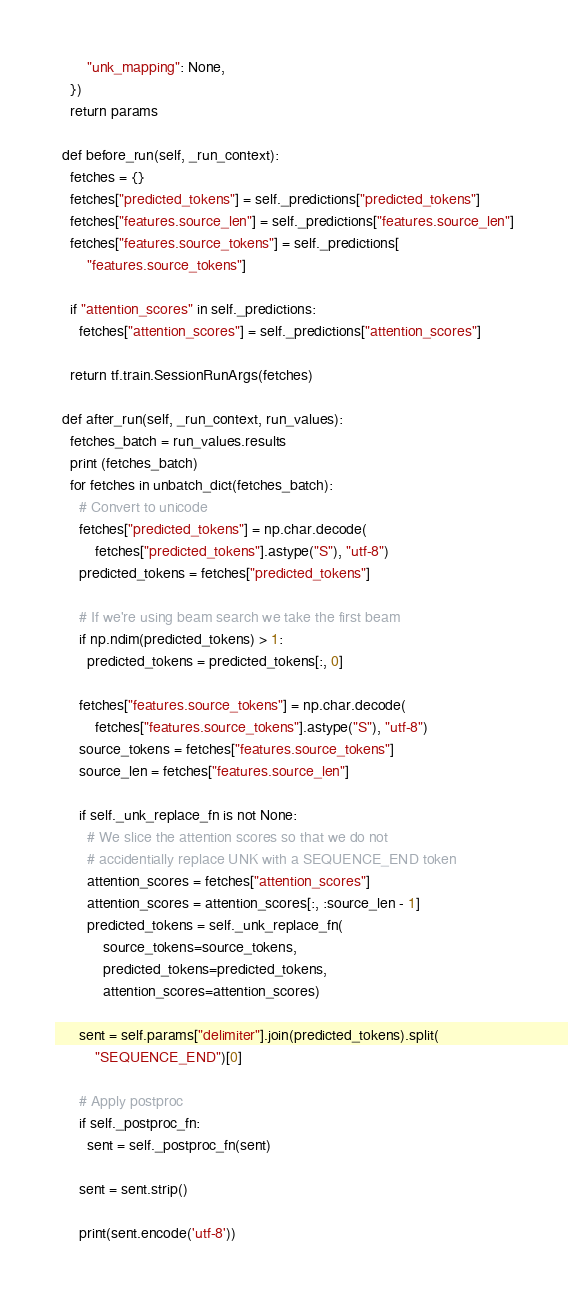<code> <loc_0><loc_0><loc_500><loc_500><_Python_>        "unk_mapping": None,
    })
    return params

  def before_run(self, _run_context):
    fetches = {}
    fetches["predicted_tokens"] = self._predictions["predicted_tokens"]
    fetches["features.source_len"] = self._predictions["features.source_len"]
    fetches["features.source_tokens"] = self._predictions[
        "features.source_tokens"]

    if "attention_scores" in self._predictions:
      fetches["attention_scores"] = self._predictions["attention_scores"]

    return tf.train.SessionRunArgs(fetches)

  def after_run(self, _run_context, run_values):
    fetches_batch = run_values.results
    print (fetches_batch)
    for fetches in unbatch_dict(fetches_batch):
      # Convert to unicode
      fetches["predicted_tokens"] = np.char.decode(
          fetches["predicted_tokens"].astype("S"), "utf-8")
      predicted_tokens = fetches["predicted_tokens"]

      # If we're using beam search we take the first beam
      if np.ndim(predicted_tokens) > 1:
        predicted_tokens = predicted_tokens[:, 0]

      fetches["features.source_tokens"] = np.char.decode(
          fetches["features.source_tokens"].astype("S"), "utf-8")
      source_tokens = fetches["features.source_tokens"]
      source_len = fetches["features.source_len"]

      if self._unk_replace_fn is not None:
        # We slice the attention scores so that we do not
        # accidentially replace UNK with a SEQUENCE_END token
        attention_scores = fetches["attention_scores"]
        attention_scores = attention_scores[:, :source_len - 1]
        predicted_tokens = self._unk_replace_fn(
            source_tokens=source_tokens,
            predicted_tokens=predicted_tokens,
            attention_scores=attention_scores)

      sent = self.params["delimiter"].join(predicted_tokens).split(
          "SEQUENCE_END")[0]

      # Apply postproc
      if self._postproc_fn:
        sent = self._postproc_fn(sent)

      sent = sent.strip()

      print(sent.encode('utf-8'))
</code> 